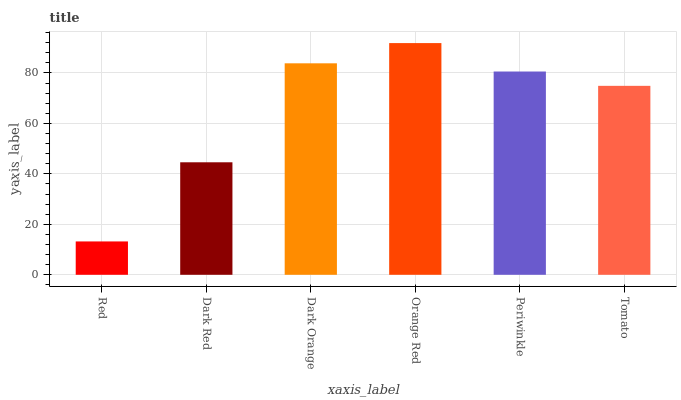Is Red the minimum?
Answer yes or no. Yes. Is Orange Red the maximum?
Answer yes or no. Yes. Is Dark Red the minimum?
Answer yes or no. No. Is Dark Red the maximum?
Answer yes or no. No. Is Dark Red greater than Red?
Answer yes or no. Yes. Is Red less than Dark Red?
Answer yes or no. Yes. Is Red greater than Dark Red?
Answer yes or no. No. Is Dark Red less than Red?
Answer yes or no. No. Is Periwinkle the high median?
Answer yes or no. Yes. Is Tomato the low median?
Answer yes or no. Yes. Is Red the high median?
Answer yes or no. No. Is Dark Red the low median?
Answer yes or no. No. 